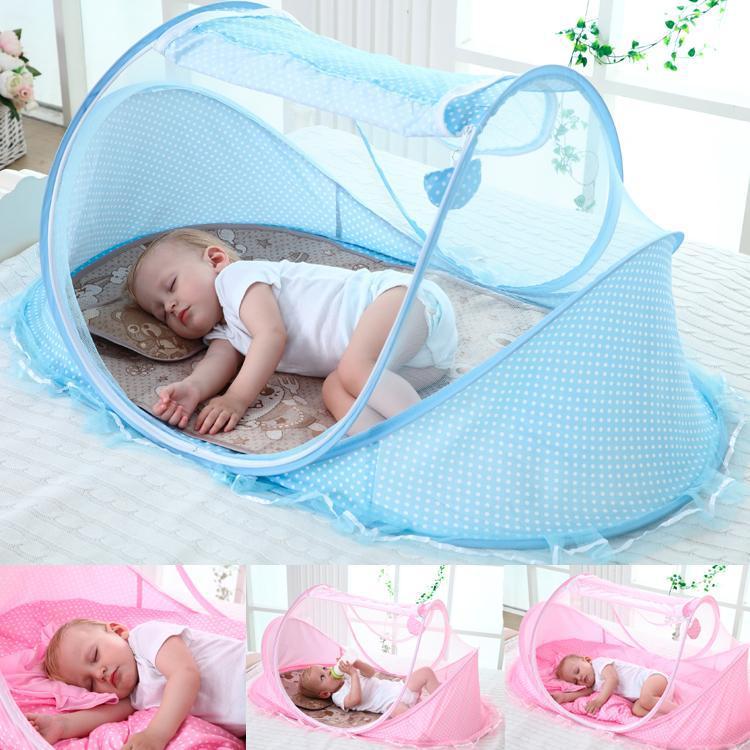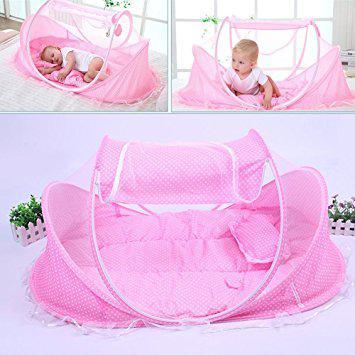The first image is the image on the left, the second image is the image on the right. Considering the images on both sides, is "One of the baby sleeper items is blue." valid? Answer yes or no. Yes. 